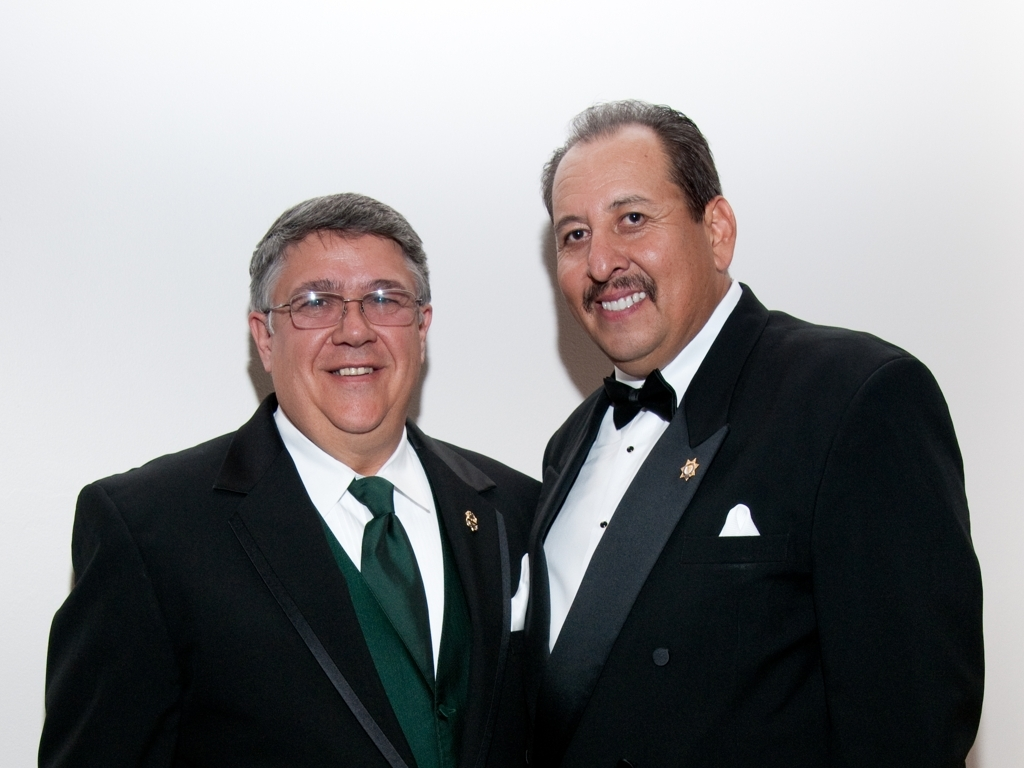Can you describe the attire the two individuals are wearing? The two individuals are dressed in formal attire. The person on the left is wearing a black tuxedo with a bow tie and a green, collared shirt. The person on the right is wearing a similar black tuxedo, but with a white shirt and a bow tie, accessorized with a lapel pin and a white pocket square. 